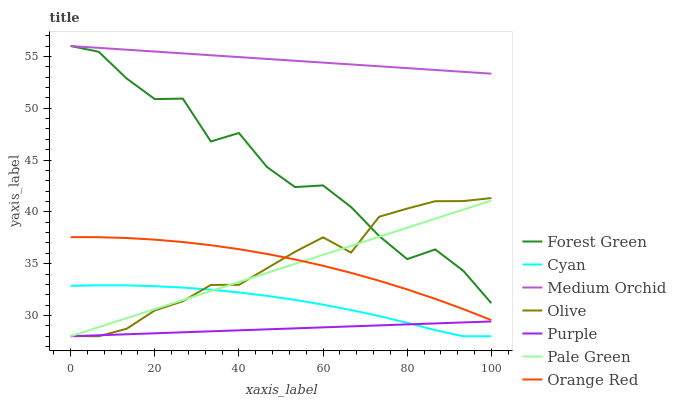Does Purple have the minimum area under the curve?
Answer yes or no. Yes. Does Medium Orchid have the maximum area under the curve?
Answer yes or no. Yes. Does Forest Green have the minimum area under the curve?
Answer yes or no. No. Does Forest Green have the maximum area under the curve?
Answer yes or no. No. Is Purple the smoothest?
Answer yes or no. Yes. Is Forest Green the roughest?
Answer yes or no. Yes. Is Medium Orchid the smoothest?
Answer yes or no. No. Is Medium Orchid the roughest?
Answer yes or no. No. Does Purple have the lowest value?
Answer yes or no. Yes. Does Forest Green have the lowest value?
Answer yes or no. No. Does Forest Green have the highest value?
Answer yes or no. Yes. Does Pale Green have the highest value?
Answer yes or no. No. Is Cyan less than Forest Green?
Answer yes or no. Yes. Is Orange Red greater than Cyan?
Answer yes or no. Yes. Does Pale Green intersect Cyan?
Answer yes or no. Yes. Is Pale Green less than Cyan?
Answer yes or no. No. Is Pale Green greater than Cyan?
Answer yes or no. No. Does Cyan intersect Forest Green?
Answer yes or no. No. 